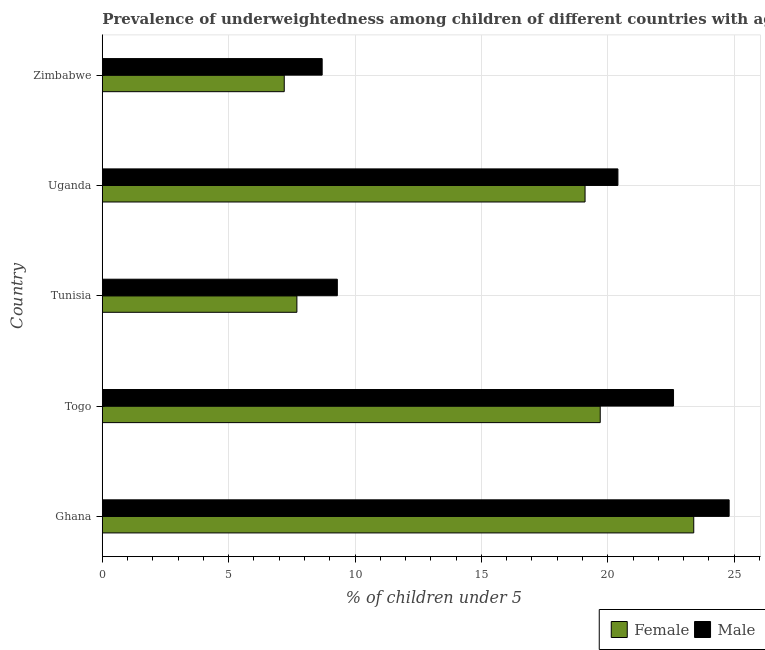How many different coloured bars are there?
Provide a succinct answer. 2. How many groups of bars are there?
Offer a terse response. 5. Are the number of bars per tick equal to the number of legend labels?
Make the answer very short. Yes. Are the number of bars on each tick of the Y-axis equal?
Make the answer very short. Yes. How many bars are there on the 4th tick from the top?
Offer a very short reply. 2. How many bars are there on the 5th tick from the bottom?
Provide a succinct answer. 2. What is the label of the 2nd group of bars from the top?
Offer a very short reply. Uganda. In how many cases, is the number of bars for a given country not equal to the number of legend labels?
Offer a very short reply. 0. What is the percentage of underweighted male children in Tunisia?
Your answer should be very brief. 9.3. Across all countries, what is the maximum percentage of underweighted female children?
Your answer should be very brief. 23.4. Across all countries, what is the minimum percentage of underweighted female children?
Provide a succinct answer. 7.2. In which country was the percentage of underweighted male children maximum?
Provide a short and direct response. Ghana. In which country was the percentage of underweighted female children minimum?
Your answer should be compact. Zimbabwe. What is the total percentage of underweighted male children in the graph?
Offer a very short reply. 85.8. What is the difference between the percentage of underweighted male children in Ghana and the percentage of underweighted female children in Tunisia?
Ensure brevity in your answer.  17.1. What is the average percentage of underweighted female children per country?
Give a very brief answer. 15.42. What is the difference between the percentage of underweighted female children and percentage of underweighted male children in Togo?
Your answer should be very brief. -2.9. In how many countries, is the percentage of underweighted male children greater than 13 %?
Your response must be concise. 3. What is the ratio of the percentage of underweighted female children in Tunisia to that in Uganda?
Your answer should be very brief. 0.4. Is the percentage of underweighted male children in Ghana less than that in Zimbabwe?
Give a very brief answer. No. What is the difference between the highest and the second highest percentage of underweighted male children?
Your answer should be compact. 2.2. What does the 1st bar from the top in Tunisia represents?
Provide a succinct answer. Male. Are all the bars in the graph horizontal?
Keep it short and to the point. Yes. How many countries are there in the graph?
Offer a very short reply. 5. How many legend labels are there?
Provide a succinct answer. 2. What is the title of the graph?
Offer a very short reply. Prevalence of underweightedness among children of different countries with age under 5 years. What is the label or title of the X-axis?
Your answer should be compact.  % of children under 5. What is the label or title of the Y-axis?
Provide a succinct answer. Country. What is the  % of children under 5 of Female in Ghana?
Offer a terse response. 23.4. What is the  % of children under 5 in Male in Ghana?
Give a very brief answer. 24.8. What is the  % of children under 5 of Female in Togo?
Keep it short and to the point. 19.7. What is the  % of children under 5 in Male in Togo?
Your answer should be compact. 22.6. What is the  % of children under 5 of Female in Tunisia?
Your response must be concise. 7.7. What is the  % of children under 5 of Male in Tunisia?
Your response must be concise. 9.3. What is the  % of children under 5 of Female in Uganda?
Your answer should be very brief. 19.1. What is the  % of children under 5 in Male in Uganda?
Give a very brief answer. 20.4. What is the  % of children under 5 of Female in Zimbabwe?
Keep it short and to the point. 7.2. What is the  % of children under 5 of Male in Zimbabwe?
Make the answer very short. 8.7. Across all countries, what is the maximum  % of children under 5 of Female?
Offer a terse response. 23.4. Across all countries, what is the maximum  % of children under 5 in Male?
Keep it short and to the point. 24.8. Across all countries, what is the minimum  % of children under 5 in Female?
Make the answer very short. 7.2. Across all countries, what is the minimum  % of children under 5 of Male?
Offer a terse response. 8.7. What is the total  % of children under 5 in Female in the graph?
Your answer should be compact. 77.1. What is the total  % of children under 5 of Male in the graph?
Your response must be concise. 85.8. What is the difference between the  % of children under 5 in Female in Ghana and that in Tunisia?
Offer a terse response. 15.7. What is the difference between the  % of children under 5 in Female in Ghana and that in Uganda?
Provide a short and direct response. 4.3. What is the difference between the  % of children under 5 in Male in Ghana and that in Uganda?
Offer a very short reply. 4.4. What is the difference between the  % of children under 5 of Male in Ghana and that in Zimbabwe?
Keep it short and to the point. 16.1. What is the difference between the  % of children under 5 in Female in Togo and that in Uganda?
Give a very brief answer. 0.6. What is the difference between the  % of children under 5 of Male in Togo and that in Uganda?
Provide a succinct answer. 2.2. What is the difference between the  % of children under 5 of Female in Togo and that in Zimbabwe?
Give a very brief answer. 12.5. What is the difference between the  % of children under 5 in Male in Togo and that in Zimbabwe?
Your answer should be very brief. 13.9. What is the difference between the  % of children under 5 in Female in Tunisia and that in Zimbabwe?
Your answer should be compact. 0.5. What is the difference between the  % of children under 5 in Male in Tunisia and that in Zimbabwe?
Offer a terse response. 0.6. What is the difference between the  % of children under 5 of Female in Uganda and that in Zimbabwe?
Your answer should be very brief. 11.9. What is the difference between the  % of children under 5 of Female in Ghana and the  % of children under 5 of Male in Togo?
Ensure brevity in your answer.  0.8. What is the difference between the  % of children under 5 of Female in Ghana and the  % of children under 5 of Male in Uganda?
Make the answer very short. 3. What is the difference between the  % of children under 5 of Female in Togo and the  % of children under 5 of Male in Uganda?
Your response must be concise. -0.7. What is the difference between the  % of children under 5 in Female in Togo and the  % of children under 5 in Male in Zimbabwe?
Give a very brief answer. 11. What is the difference between the  % of children under 5 of Female in Uganda and the  % of children under 5 of Male in Zimbabwe?
Offer a very short reply. 10.4. What is the average  % of children under 5 of Female per country?
Make the answer very short. 15.42. What is the average  % of children under 5 in Male per country?
Offer a terse response. 17.16. What is the difference between the  % of children under 5 of Female and  % of children under 5 of Male in Togo?
Your response must be concise. -2.9. What is the ratio of the  % of children under 5 of Female in Ghana to that in Togo?
Your answer should be very brief. 1.19. What is the ratio of the  % of children under 5 of Male in Ghana to that in Togo?
Give a very brief answer. 1.1. What is the ratio of the  % of children under 5 in Female in Ghana to that in Tunisia?
Provide a succinct answer. 3.04. What is the ratio of the  % of children under 5 in Male in Ghana to that in Tunisia?
Offer a terse response. 2.67. What is the ratio of the  % of children under 5 in Female in Ghana to that in Uganda?
Offer a very short reply. 1.23. What is the ratio of the  % of children under 5 of Male in Ghana to that in Uganda?
Make the answer very short. 1.22. What is the ratio of the  % of children under 5 in Female in Ghana to that in Zimbabwe?
Keep it short and to the point. 3.25. What is the ratio of the  % of children under 5 of Male in Ghana to that in Zimbabwe?
Ensure brevity in your answer.  2.85. What is the ratio of the  % of children under 5 in Female in Togo to that in Tunisia?
Provide a short and direct response. 2.56. What is the ratio of the  % of children under 5 of Male in Togo to that in Tunisia?
Give a very brief answer. 2.43. What is the ratio of the  % of children under 5 in Female in Togo to that in Uganda?
Your answer should be very brief. 1.03. What is the ratio of the  % of children under 5 in Male in Togo to that in Uganda?
Offer a terse response. 1.11. What is the ratio of the  % of children under 5 of Female in Togo to that in Zimbabwe?
Provide a succinct answer. 2.74. What is the ratio of the  % of children under 5 of Male in Togo to that in Zimbabwe?
Ensure brevity in your answer.  2.6. What is the ratio of the  % of children under 5 in Female in Tunisia to that in Uganda?
Provide a succinct answer. 0.4. What is the ratio of the  % of children under 5 in Male in Tunisia to that in Uganda?
Provide a short and direct response. 0.46. What is the ratio of the  % of children under 5 of Female in Tunisia to that in Zimbabwe?
Keep it short and to the point. 1.07. What is the ratio of the  % of children under 5 of Male in Tunisia to that in Zimbabwe?
Your answer should be very brief. 1.07. What is the ratio of the  % of children under 5 of Female in Uganda to that in Zimbabwe?
Provide a succinct answer. 2.65. What is the ratio of the  % of children under 5 of Male in Uganda to that in Zimbabwe?
Your answer should be very brief. 2.34. What is the difference between the highest and the second highest  % of children under 5 of Female?
Provide a succinct answer. 3.7. What is the difference between the highest and the second highest  % of children under 5 in Male?
Your answer should be compact. 2.2. What is the difference between the highest and the lowest  % of children under 5 in Female?
Ensure brevity in your answer.  16.2. What is the difference between the highest and the lowest  % of children under 5 of Male?
Offer a very short reply. 16.1. 